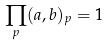Convert formula to latex. <formula><loc_0><loc_0><loc_500><loc_500>\prod _ { p } ( a , b ) _ { p } = 1</formula> 